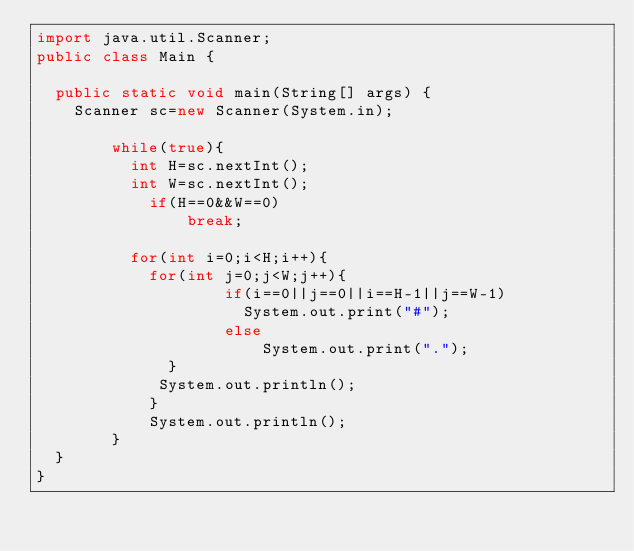Convert code to text. <code><loc_0><loc_0><loc_500><loc_500><_Java_>import java.util.Scanner;
public class Main {

	public static void main(String[] args) {
		Scanner sc=new Scanner(System.in);
        
        while(true){
        	int H=sc.nextInt();
        	int W=sc.nextInt();
            if(H==0&&W==0)
                break;
        
        	for(int i=0;i<H;i++){
        		for(int j=0;j<W;j++){
                    if(i==0||j==0||i==H-1||j==W-1)
                    	System.out.print("#");
                    else
                        System.out.print(".");
            	}
           	 System.out.println();
            }
            System.out.println();
        }
	}
}

</code> 